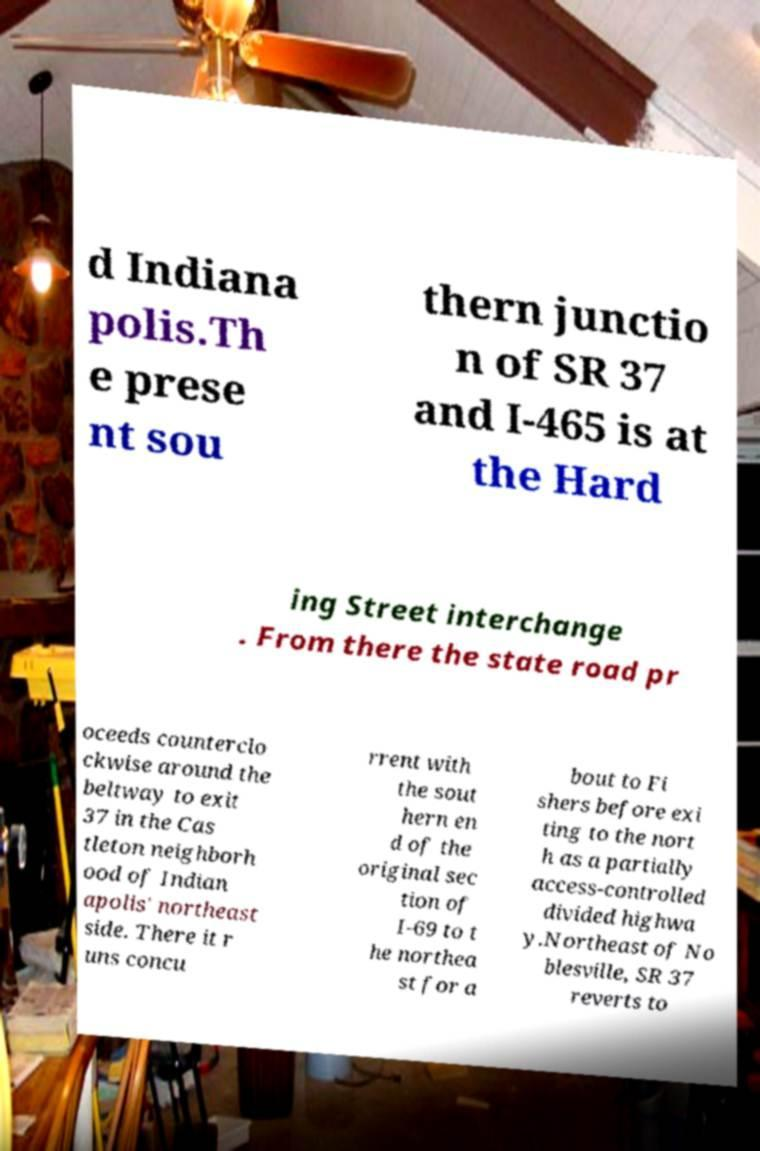Can you read and provide the text displayed in the image?This photo seems to have some interesting text. Can you extract and type it out for me? d Indiana polis.Th e prese nt sou thern junctio n of SR 37 and I-465 is at the Hard ing Street interchange . From there the state road pr oceeds counterclo ckwise around the beltway to exit 37 in the Cas tleton neighborh ood of Indian apolis' northeast side. There it r uns concu rrent with the sout hern en d of the original sec tion of I-69 to t he northea st for a bout to Fi shers before exi ting to the nort h as a partially access-controlled divided highwa y.Northeast of No blesville, SR 37 reverts to 